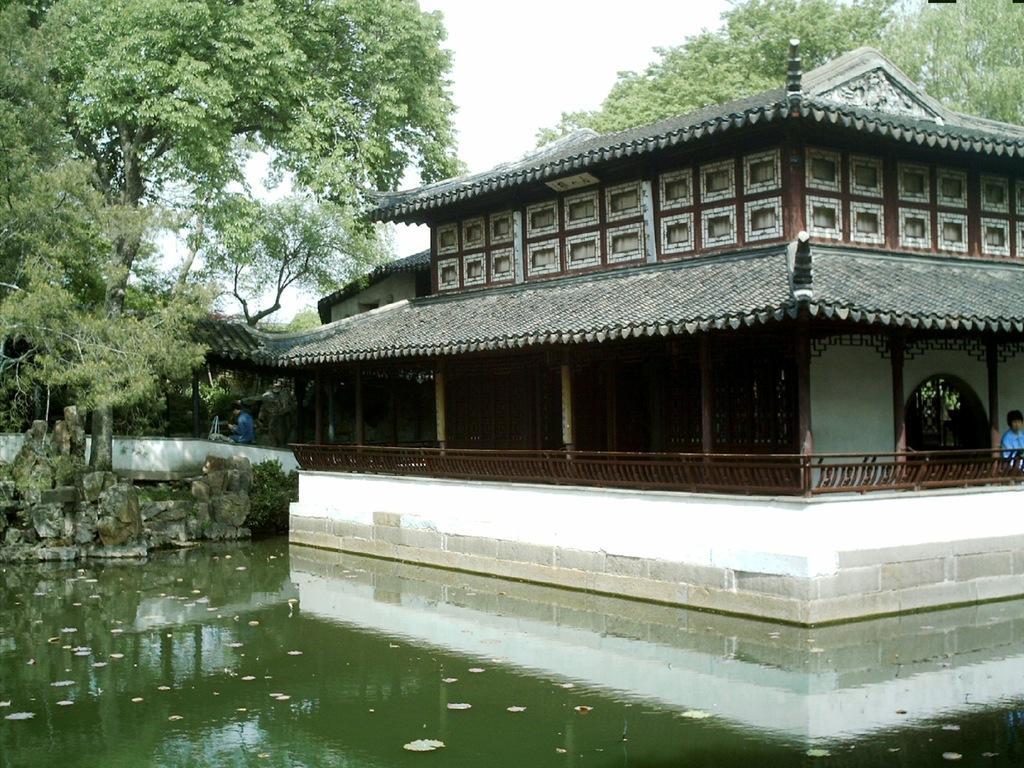Could you give a brief overview of what you see in this image? In this image I can see at the bottom there is the water, on the right side there is a house. On the left side there are trees, at the top there is the sky. 